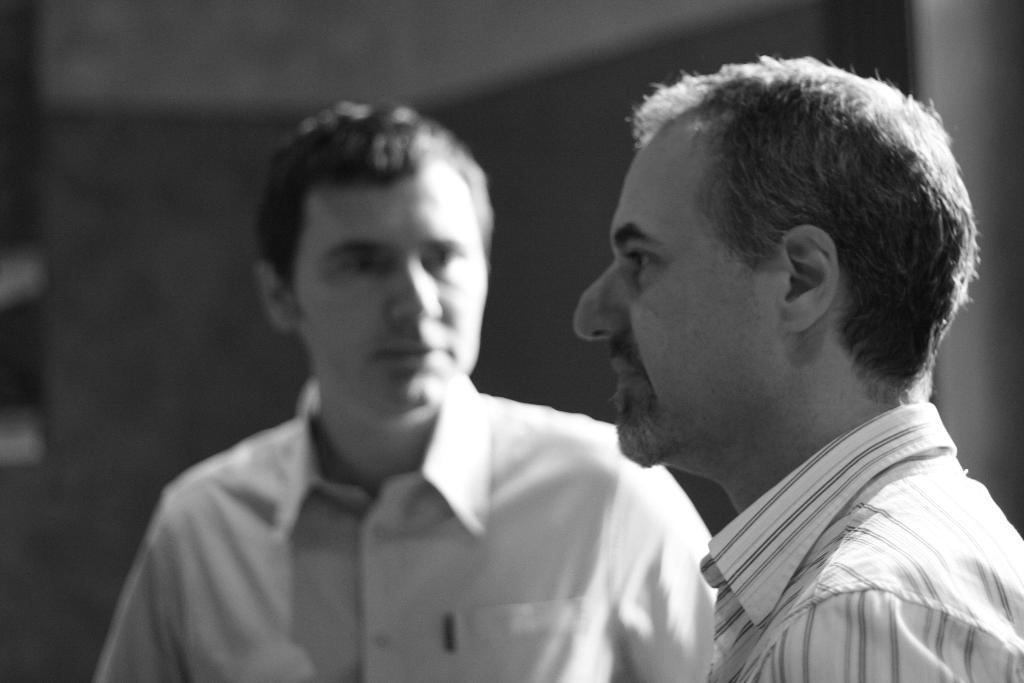In one or two sentences, can you explain what this image depicts? This is a black and white picture. In the foreground is a person standing. In the center of the picture of there is another person standing. The background is blurred. 